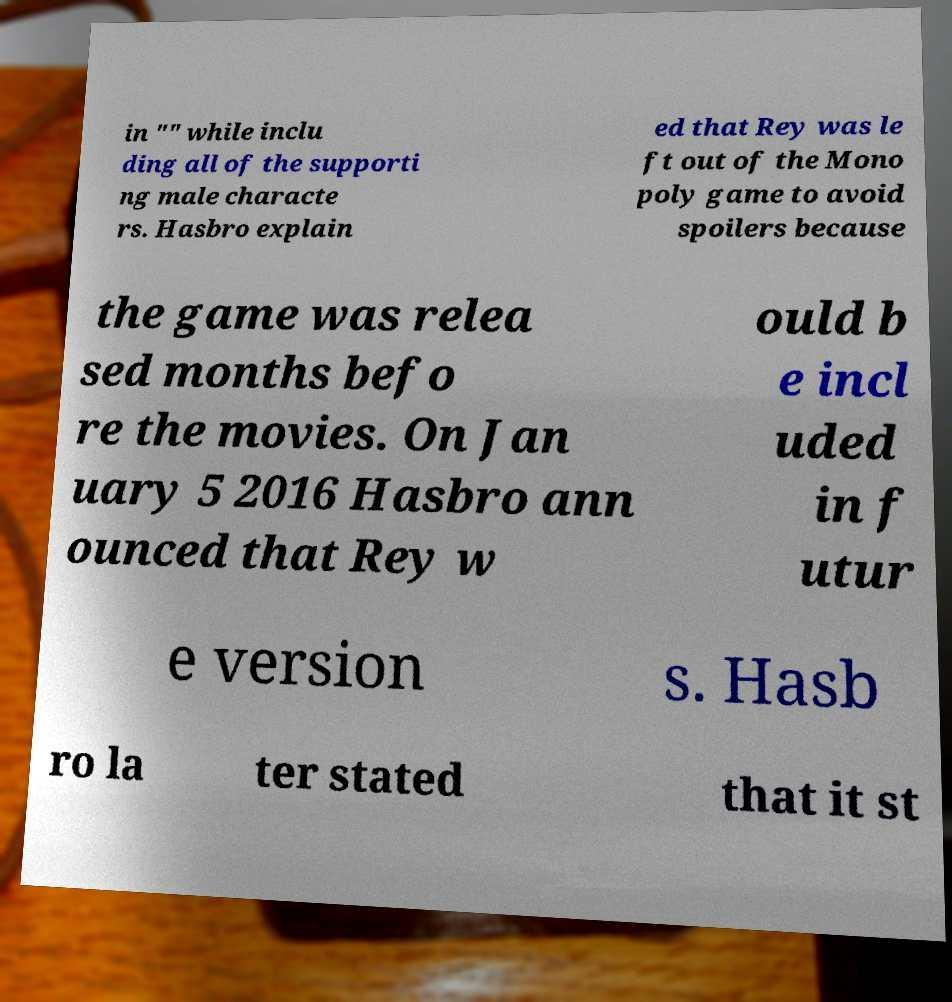Could you extract and type out the text from this image? in "" while inclu ding all of the supporti ng male characte rs. Hasbro explain ed that Rey was le ft out of the Mono poly game to avoid spoilers because the game was relea sed months befo re the movies. On Jan uary 5 2016 Hasbro ann ounced that Rey w ould b e incl uded in f utur e version s. Hasb ro la ter stated that it st 